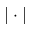Convert formula to latex. <formula><loc_0><loc_0><loc_500><loc_500>| \cdot |</formula> 